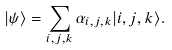<formula> <loc_0><loc_0><loc_500><loc_500>| \psi \rangle = \sum _ { i , j , k } \alpha _ { i , j , k } | i , j , k \rangle .</formula> 